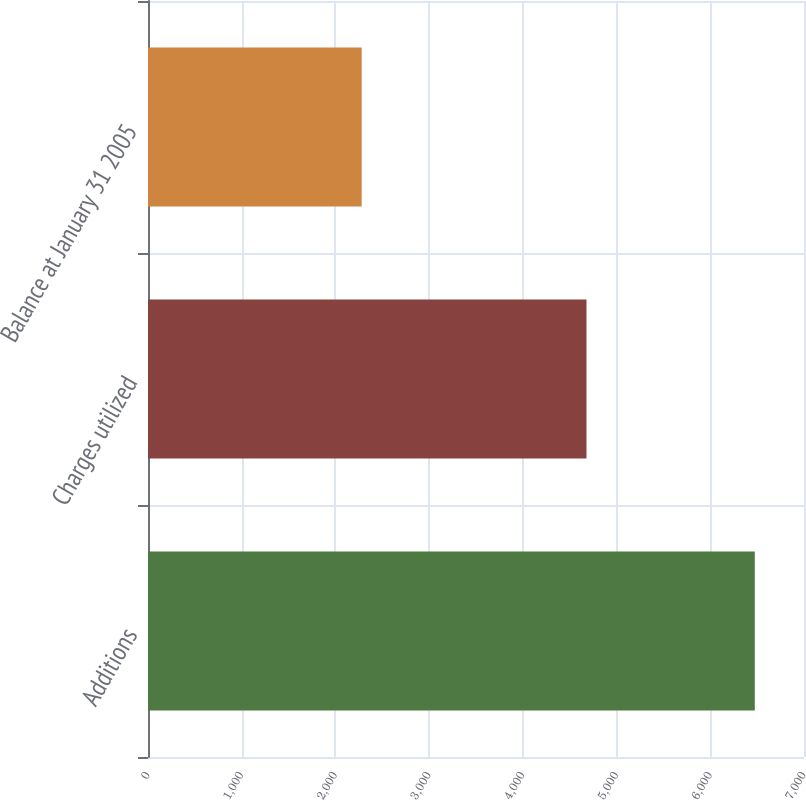<chart> <loc_0><loc_0><loc_500><loc_500><bar_chart><fcel>Additions<fcel>Charges utilized<fcel>Balance at January 31 2005<nl><fcel>6475<fcel>4679<fcel>2280<nl></chart> 